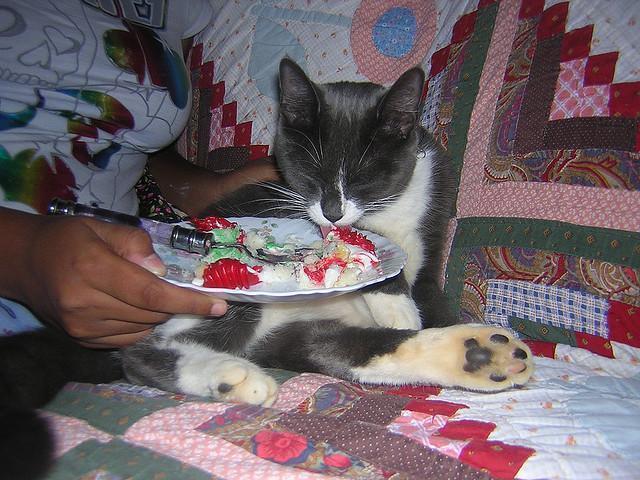How many toes does cats are supposed to have?
Indicate the correct choice and explain in the format: 'Answer: answer
Rationale: rationale.'
Options: 18, 24, 11, 14. Answer: 18.
Rationale: A cat should have 18 toes. 